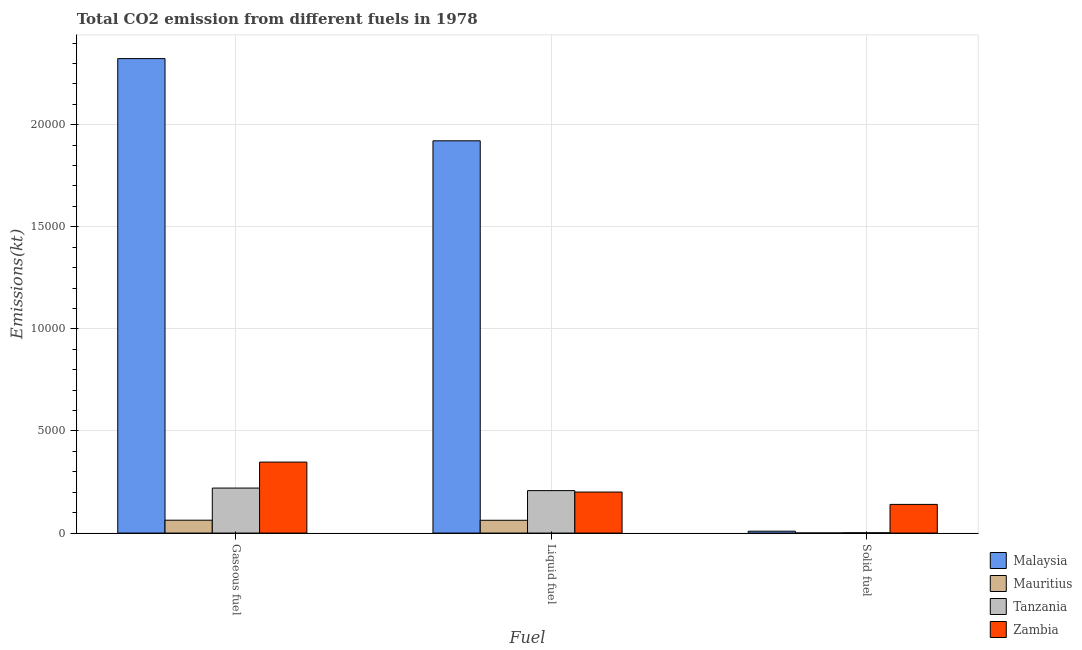How many different coloured bars are there?
Your answer should be compact. 4. Are the number of bars per tick equal to the number of legend labels?
Your response must be concise. Yes. Are the number of bars on each tick of the X-axis equal?
Offer a very short reply. Yes. What is the label of the 2nd group of bars from the left?
Provide a succinct answer. Liquid fuel. What is the amount of co2 emissions from solid fuel in Mauritius?
Ensure brevity in your answer.  3.67. Across all countries, what is the maximum amount of co2 emissions from liquid fuel?
Your answer should be compact. 1.92e+04. Across all countries, what is the minimum amount of co2 emissions from liquid fuel?
Ensure brevity in your answer.  627.06. In which country was the amount of co2 emissions from solid fuel maximum?
Ensure brevity in your answer.  Zambia. In which country was the amount of co2 emissions from solid fuel minimum?
Keep it short and to the point. Mauritius. What is the total amount of co2 emissions from liquid fuel in the graph?
Provide a succinct answer. 2.39e+04. What is the difference between the amount of co2 emissions from gaseous fuel in Malaysia and that in Mauritius?
Offer a terse response. 2.26e+04. What is the difference between the amount of co2 emissions from liquid fuel in Mauritius and the amount of co2 emissions from solid fuel in Zambia?
Offer a very short reply. -777.4. What is the average amount of co2 emissions from liquid fuel per country?
Your answer should be compact. 5981.79. What is the difference between the amount of co2 emissions from solid fuel and amount of co2 emissions from gaseous fuel in Zambia?
Make the answer very short. -2071.85. In how many countries, is the amount of co2 emissions from solid fuel greater than 15000 kt?
Your response must be concise. 0. What is the ratio of the amount of co2 emissions from gaseous fuel in Mauritius to that in Malaysia?
Your answer should be compact. 0.03. What is the difference between the highest and the second highest amount of co2 emissions from gaseous fuel?
Ensure brevity in your answer.  1.98e+04. What is the difference between the highest and the lowest amount of co2 emissions from solid fuel?
Give a very brief answer. 1400.79. In how many countries, is the amount of co2 emissions from gaseous fuel greater than the average amount of co2 emissions from gaseous fuel taken over all countries?
Make the answer very short. 1. Is the sum of the amount of co2 emissions from liquid fuel in Mauritius and Tanzania greater than the maximum amount of co2 emissions from solid fuel across all countries?
Ensure brevity in your answer.  Yes. What does the 2nd bar from the left in Solid fuel represents?
Offer a terse response. Mauritius. What does the 4th bar from the right in Solid fuel represents?
Keep it short and to the point. Malaysia. How many countries are there in the graph?
Your answer should be compact. 4. Are the values on the major ticks of Y-axis written in scientific E-notation?
Make the answer very short. No. Does the graph contain any zero values?
Ensure brevity in your answer.  No. Where does the legend appear in the graph?
Keep it short and to the point. Bottom right. What is the title of the graph?
Provide a short and direct response. Total CO2 emission from different fuels in 1978. Does "Djibouti" appear as one of the legend labels in the graph?
Your answer should be very brief. No. What is the label or title of the X-axis?
Offer a very short reply. Fuel. What is the label or title of the Y-axis?
Ensure brevity in your answer.  Emissions(kt). What is the Emissions(kt) of Malaysia in Gaseous fuel?
Your answer should be compact. 2.32e+04. What is the Emissions(kt) in Mauritius in Gaseous fuel?
Provide a short and direct response. 630.72. What is the Emissions(kt) of Tanzania in Gaseous fuel?
Your answer should be very brief. 2203.87. What is the Emissions(kt) in Zambia in Gaseous fuel?
Your answer should be compact. 3476.32. What is the Emissions(kt) of Malaysia in Liquid fuel?
Ensure brevity in your answer.  1.92e+04. What is the Emissions(kt) in Mauritius in Liquid fuel?
Offer a very short reply. 627.06. What is the Emissions(kt) of Tanzania in Liquid fuel?
Ensure brevity in your answer.  2079.19. What is the Emissions(kt) in Zambia in Liquid fuel?
Your answer should be very brief. 2009.52. What is the Emissions(kt) in Malaysia in Solid fuel?
Your answer should be very brief. 91.67. What is the Emissions(kt) in Mauritius in Solid fuel?
Provide a succinct answer. 3.67. What is the Emissions(kt) of Tanzania in Solid fuel?
Offer a terse response. 14.67. What is the Emissions(kt) in Zambia in Solid fuel?
Offer a terse response. 1404.46. Across all Fuel, what is the maximum Emissions(kt) in Malaysia?
Your answer should be compact. 2.32e+04. Across all Fuel, what is the maximum Emissions(kt) of Mauritius?
Provide a short and direct response. 630.72. Across all Fuel, what is the maximum Emissions(kt) in Tanzania?
Provide a succinct answer. 2203.87. Across all Fuel, what is the maximum Emissions(kt) of Zambia?
Make the answer very short. 3476.32. Across all Fuel, what is the minimum Emissions(kt) in Malaysia?
Offer a terse response. 91.67. Across all Fuel, what is the minimum Emissions(kt) in Mauritius?
Give a very brief answer. 3.67. Across all Fuel, what is the minimum Emissions(kt) in Tanzania?
Ensure brevity in your answer.  14.67. Across all Fuel, what is the minimum Emissions(kt) in Zambia?
Your answer should be very brief. 1404.46. What is the total Emissions(kt) of Malaysia in the graph?
Your response must be concise. 4.25e+04. What is the total Emissions(kt) in Mauritius in the graph?
Keep it short and to the point. 1261.45. What is the total Emissions(kt) in Tanzania in the graph?
Your answer should be very brief. 4297.72. What is the total Emissions(kt) in Zambia in the graph?
Make the answer very short. 6890.29. What is the difference between the Emissions(kt) in Malaysia in Gaseous fuel and that in Liquid fuel?
Offer a very short reply. 4026.37. What is the difference between the Emissions(kt) of Mauritius in Gaseous fuel and that in Liquid fuel?
Give a very brief answer. 3.67. What is the difference between the Emissions(kt) of Tanzania in Gaseous fuel and that in Liquid fuel?
Your answer should be very brief. 124.68. What is the difference between the Emissions(kt) in Zambia in Gaseous fuel and that in Liquid fuel?
Your answer should be very brief. 1466.8. What is the difference between the Emissions(kt) in Malaysia in Gaseous fuel and that in Solid fuel?
Ensure brevity in your answer.  2.31e+04. What is the difference between the Emissions(kt) in Mauritius in Gaseous fuel and that in Solid fuel?
Give a very brief answer. 627.06. What is the difference between the Emissions(kt) in Tanzania in Gaseous fuel and that in Solid fuel?
Offer a very short reply. 2189.2. What is the difference between the Emissions(kt) in Zambia in Gaseous fuel and that in Solid fuel?
Your answer should be compact. 2071.86. What is the difference between the Emissions(kt) in Malaysia in Liquid fuel and that in Solid fuel?
Provide a succinct answer. 1.91e+04. What is the difference between the Emissions(kt) of Mauritius in Liquid fuel and that in Solid fuel?
Ensure brevity in your answer.  623.39. What is the difference between the Emissions(kt) of Tanzania in Liquid fuel and that in Solid fuel?
Your answer should be very brief. 2064.52. What is the difference between the Emissions(kt) of Zambia in Liquid fuel and that in Solid fuel?
Keep it short and to the point. 605.05. What is the difference between the Emissions(kt) of Malaysia in Gaseous fuel and the Emissions(kt) of Mauritius in Liquid fuel?
Make the answer very short. 2.26e+04. What is the difference between the Emissions(kt) in Malaysia in Gaseous fuel and the Emissions(kt) in Tanzania in Liquid fuel?
Your answer should be compact. 2.12e+04. What is the difference between the Emissions(kt) of Malaysia in Gaseous fuel and the Emissions(kt) of Zambia in Liquid fuel?
Provide a succinct answer. 2.12e+04. What is the difference between the Emissions(kt) of Mauritius in Gaseous fuel and the Emissions(kt) of Tanzania in Liquid fuel?
Provide a short and direct response. -1448.46. What is the difference between the Emissions(kt) in Mauritius in Gaseous fuel and the Emissions(kt) in Zambia in Liquid fuel?
Make the answer very short. -1378.79. What is the difference between the Emissions(kt) in Tanzania in Gaseous fuel and the Emissions(kt) in Zambia in Liquid fuel?
Offer a very short reply. 194.35. What is the difference between the Emissions(kt) of Malaysia in Gaseous fuel and the Emissions(kt) of Mauritius in Solid fuel?
Your answer should be very brief. 2.32e+04. What is the difference between the Emissions(kt) of Malaysia in Gaseous fuel and the Emissions(kt) of Tanzania in Solid fuel?
Provide a short and direct response. 2.32e+04. What is the difference between the Emissions(kt) in Malaysia in Gaseous fuel and the Emissions(kt) in Zambia in Solid fuel?
Your response must be concise. 2.18e+04. What is the difference between the Emissions(kt) of Mauritius in Gaseous fuel and the Emissions(kt) of Tanzania in Solid fuel?
Keep it short and to the point. 616.06. What is the difference between the Emissions(kt) of Mauritius in Gaseous fuel and the Emissions(kt) of Zambia in Solid fuel?
Give a very brief answer. -773.74. What is the difference between the Emissions(kt) in Tanzania in Gaseous fuel and the Emissions(kt) in Zambia in Solid fuel?
Your answer should be compact. 799.41. What is the difference between the Emissions(kt) in Malaysia in Liquid fuel and the Emissions(kt) in Mauritius in Solid fuel?
Offer a terse response. 1.92e+04. What is the difference between the Emissions(kt) in Malaysia in Liquid fuel and the Emissions(kt) in Tanzania in Solid fuel?
Offer a very short reply. 1.92e+04. What is the difference between the Emissions(kt) of Malaysia in Liquid fuel and the Emissions(kt) of Zambia in Solid fuel?
Your answer should be very brief. 1.78e+04. What is the difference between the Emissions(kt) in Mauritius in Liquid fuel and the Emissions(kt) in Tanzania in Solid fuel?
Your answer should be compact. 612.39. What is the difference between the Emissions(kt) of Mauritius in Liquid fuel and the Emissions(kt) of Zambia in Solid fuel?
Offer a very short reply. -777.4. What is the difference between the Emissions(kt) in Tanzania in Liquid fuel and the Emissions(kt) in Zambia in Solid fuel?
Provide a succinct answer. 674.73. What is the average Emissions(kt) in Malaysia per Fuel?
Offer a terse response. 1.42e+04. What is the average Emissions(kt) of Mauritius per Fuel?
Offer a very short reply. 420.48. What is the average Emissions(kt) of Tanzania per Fuel?
Your response must be concise. 1432.57. What is the average Emissions(kt) in Zambia per Fuel?
Offer a terse response. 2296.76. What is the difference between the Emissions(kt) of Malaysia and Emissions(kt) of Mauritius in Gaseous fuel?
Ensure brevity in your answer.  2.26e+04. What is the difference between the Emissions(kt) in Malaysia and Emissions(kt) in Tanzania in Gaseous fuel?
Your response must be concise. 2.10e+04. What is the difference between the Emissions(kt) of Malaysia and Emissions(kt) of Zambia in Gaseous fuel?
Your answer should be compact. 1.98e+04. What is the difference between the Emissions(kt) in Mauritius and Emissions(kt) in Tanzania in Gaseous fuel?
Offer a very short reply. -1573.14. What is the difference between the Emissions(kt) of Mauritius and Emissions(kt) of Zambia in Gaseous fuel?
Ensure brevity in your answer.  -2845.59. What is the difference between the Emissions(kt) in Tanzania and Emissions(kt) in Zambia in Gaseous fuel?
Make the answer very short. -1272.45. What is the difference between the Emissions(kt) in Malaysia and Emissions(kt) in Mauritius in Liquid fuel?
Your answer should be very brief. 1.86e+04. What is the difference between the Emissions(kt) of Malaysia and Emissions(kt) of Tanzania in Liquid fuel?
Make the answer very short. 1.71e+04. What is the difference between the Emissions(kt) in Malaysia and Emissions(kt) in Zambia in Liquid fuel?
Keep it short and to the point. 1.72e+04. What is the difference between the Emissions(kt) in Mauritius and Emissions(kt) in Tanzania in Liquid fuel?
Your answer should be compact. -1452.13. What is the difference between the Emissions(kt) in Mauritius and Emissions(kt) in Zambia in Liquid fuel?
Provide a short and direct response. -1382.46. What is the difference between the Emissions(kt) of Tanzania and Emissions(kt) of Zambia in Liquid fuel?
Provide a succinct answer. 69.67. What is the difference between the Emissions(kt) in Malaysia and Emissions(kt) in Mauritius in Solid fuel?
Offer a terse response. 88.01. What is the difference between the Emissions(kt) of Malaysia and Emissions(kt) of Tanzania in Solid fuel?
Keep it short and to the point. 77.01. What is the difference between the Emissions(kt) of Malaysia and Emissions(kt) of Zambia in Solid fuel?
Provide a succinct answer. -1312.79. What is the difference between the Emissions(kt) in Mauritius and Emissions(kt) in Tanzania in Solid fuel?
Your response must be concise. -11. What is the difference between the Emissions(kt) in Mauritius and Emissions(kt) in Zambia in Solid fuel?
Keep it short and to the point. -1400.79. What is the difference between the Emissions(kt) of Tanzania and Emissions(kt) of Zambia in Solid fuel?
Make the answer very short. -1389.79. What is the ratio of the Emissions(kt) of Malaysia in Gaseous fuel to that in Liquid fuel?
Your answer should be compact. 1.21. What is the ratio of the Emissions(kt) of Mauritius in Gaseous fuel to that in Liquid fuel?
Ensure brevity in your answer.  1.01. What is the ratio of the Emissions(kt) of Tanzania in Gaseous fuel to that in Liquid fuel?
Your answer should be very brief. 1.06. What is the ratio of the Emissions(kt) in Zambia in Gaseous fuel to that in Liquid fuel?
Your response must be concise. 1.73. What is the ratio of the Emissions(kt) in Malaysia in Gaseous fuel to that in Solid fuel?
Make the answer very short. 253.48. What is the ratio of the Emissions(kt) in Mauritius in Gaseous fuel to that in Solid fuel?
Your answer should be very brief. 172. What is the ratio of the Emissions(kt) of Tanzania in Gaseous fuel to that in Solid fuel?
Provide a short and direct response. 150.25. What is the ratio of the Emissions(kt) in Zambia in Gaseous fuel to that in Solid fuel?
Provide a succinct answer. 2.48. What is the ratio of the Emissions(kt) of Malaysia in Liquid fuel to that in Solid fuel?
Offer a very short reply. 209.56. What is the ratio of the Emissions(kt) of Mauritius in Liquid fuel to that in Solid fuel?
Make the answer very short. 171. What is the ratio of the Emissions(kt) in Tanzania in Liquid fuel to that in Solid fuel?
Give a very brief answer. 141.75. What is the ratio of the Emissions(kt) in Zambia in Liquid fuel to that in Solid fuel?
Provide a short and direct response. 1.43. What is the difference between the highest and the second highest Emissions(kt) of Malaysia?
Offer a very short reply. 4026.37. What is the difference between the highest and the second highest Emissions(kt) of Mauritius?
Provide a short and direct response. 3.67. What is the difference between the highest and the second highest Emissions(kt) of Tanzania?
Your response must be concise. 124.68. What is the difference between the highest and the second highest Emissions(kt) of Zambia?
Your response must be concise. 1466.8. What is the difference between the highest and the lowest Emissions(kt) of Malaysia?
Provide a succinct answer. 2.31e+04. What is the difference between the highest and the lowest Emissions(kt) of Mauritius?
Your answer should be very brief. 627.06. What is the difference between the highest and the lowest Emissions(kt) of Tanzania?
Provide a short and direct response. 2189.2. What is the difference between the highest and the lowest Emissions(kt) of Zambia?
Your response must be concise. 2071.86. 